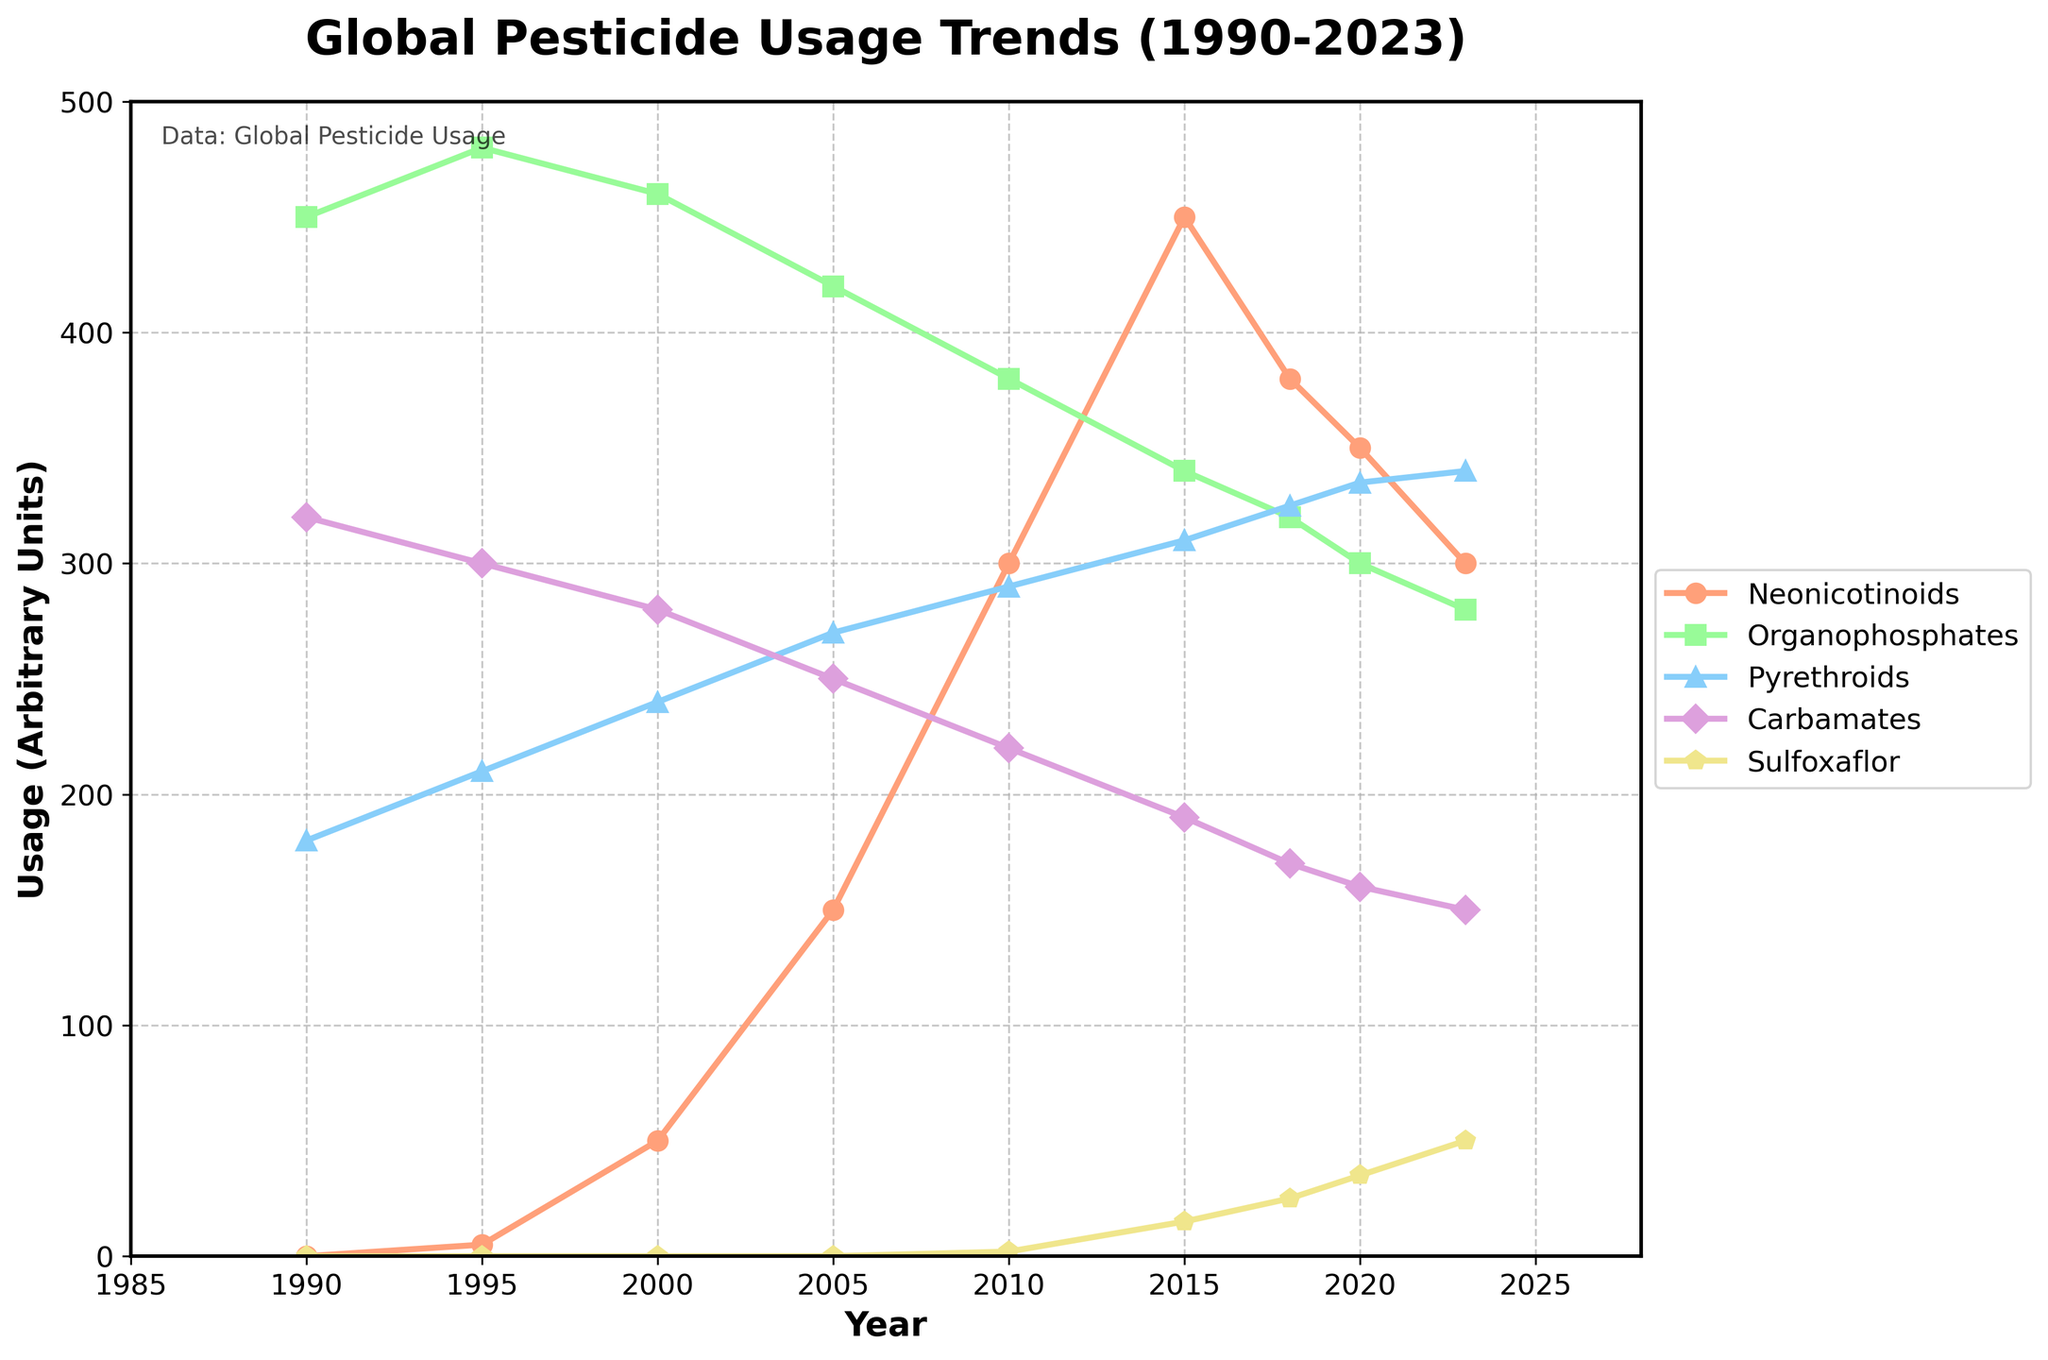Which pesticide type showed the largest increase in usage between 1990 and 2023? To determine this, we subtract the usage values for each pesticide type in 1990 from their values in 2023. For Neonicotinoids: 300 - 0 = 300, Organophosphates: 280 - 450 = -170, Pyrethroids: 340 - 180 = 160, Carbamates: 150 - 320 = -170, Sulfoxaflor: 50 - 0 = 50. The largest increase is observed in Neonicotinoids.
Answer: Neonicotinoids How does the trend of Neonicotinoids compare to Organophosphates over the period? Neonicotinoids usage increases dramatically from 0 in 1990 to a peak of 450 in 2015, followed by a decline to 300 in 2023. In contrast, Organophosphates usage starts high at 450 in 1990 and steadily decreases to 280 in 2023.
Answer: Neonicotinoids increased then decreased, Organophosphates steadily decreased Which pesticide type had consistent decline throughout the observed years? Observing the trends of each pesticide type over the years, Organophosphates consistently decrease from 450 in 1990 to 280 in 2023.
Answer: Organophosphates Between which years did Neonicotinoids see the largest change in usage? By calculating the absolute differences between consecutive years, we find that Neonicotinoids increased by 150 from 2000 (50) to 2005 (150), which is the largest change observed.
Answer: 2000 to 2005 What is the average usage of Pyrethroids from 1990 to 2023? To find the average, we sum the usage values of Pyrethroids for each year and divide by the number of years: (180 + 210 + 240 + 270 + 290 + 310 + 325 + 335 + 340) / 9 = 2500 / 9 ≈ 278.
Answer: ~278 In which year did Carbamates usage first fall below 200 units? Observing the trend of Carbamates, we see that it first falls below 200 units in 2015 (190).
Answer: 2015 What is the difference in usage between Sulfoxaflor in 2023 and 2010? Subtracting the two values, we get 50 (2023) - 2 (2010) = 48.
Answer: 48 How much more Sulfoxaflor was used in 2020 compared to 2015? Sulfoxaflor in 2020 (35) and in 2015 (15) differ by 35 - 15 = 20.
Answer: 20 Which pesticide type had the highest usage in the year 2000? By checking the values for each pesticide type in 2000, we see that Organophosphates had the highest usage at 460.
Answer: Organophosphates 